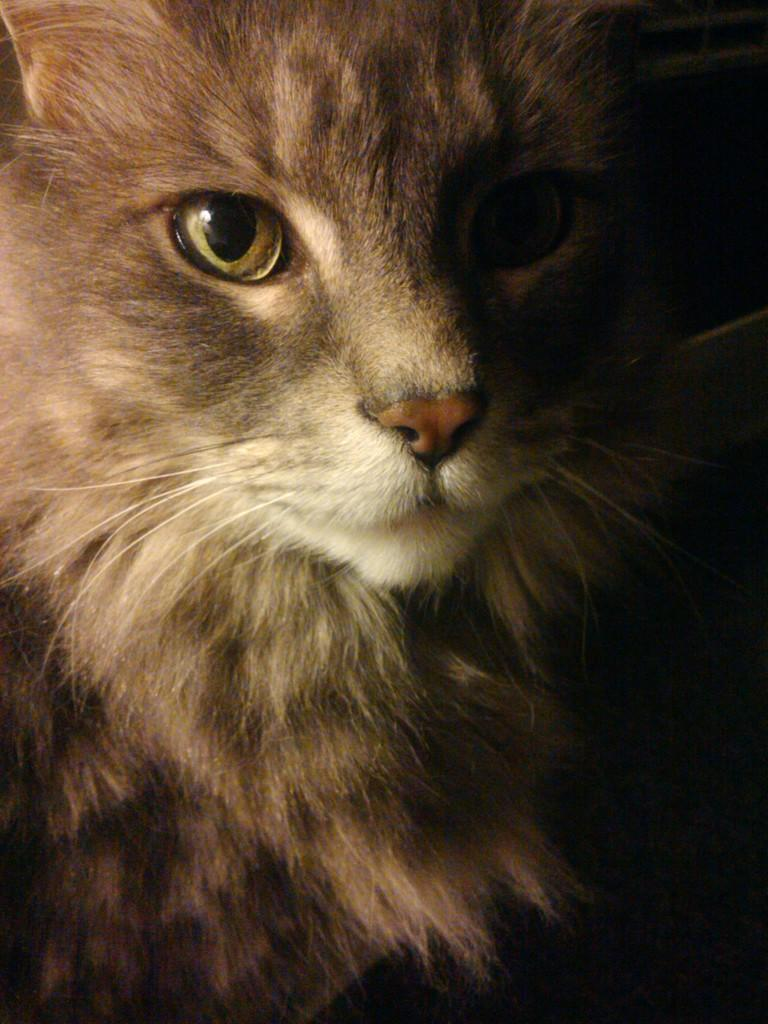What animal is present in the image? There is a cat in the picture. What is the cat doing in the image? The cat is looking at the camera. What can be observed about the color on the right side of the image? The right side of the image appears to be black in color. Can you describe the possible lighting conditions in the image? The picture might have been taken in a dark environment. What sound does the hen make in the image? There is no hen present in the image, so it is not possible to determine the sound it might make. 